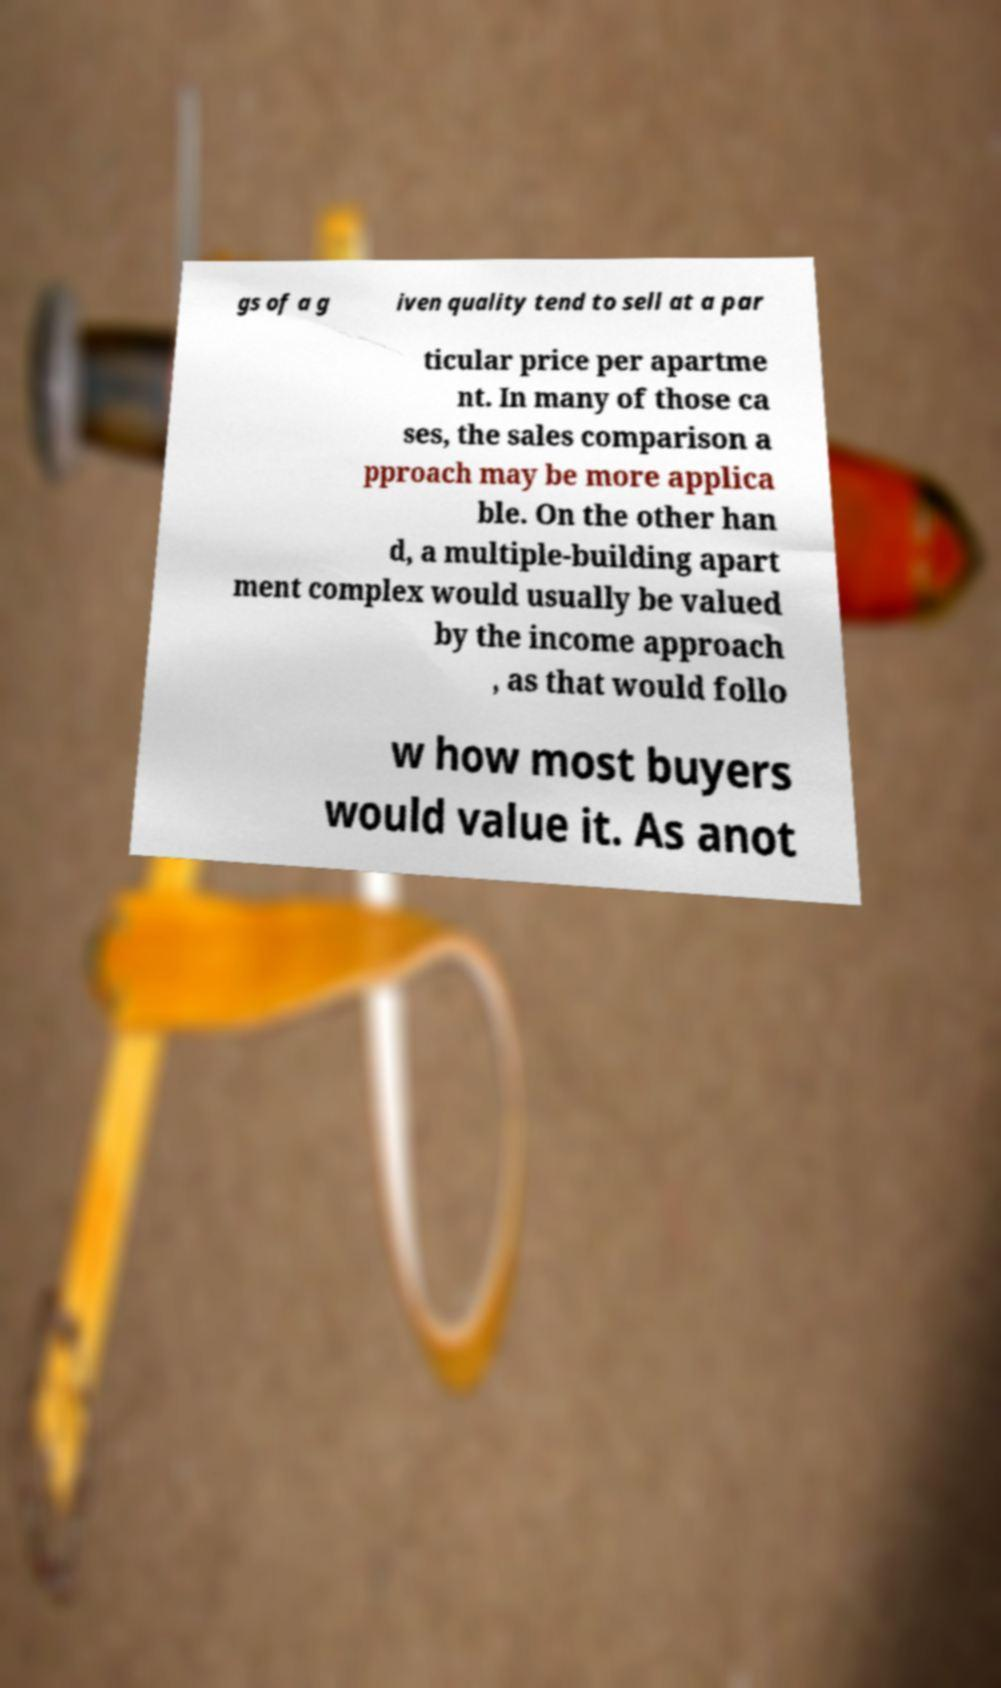There's text embedded in this image that I need extracted. Can you transcribe it verbatim? gs of a g iven quality tend to sell at a par ticular price per apartme nt. In many of those ca ses, the sales comparison a pproach may be more applica ble. On the other han d, a multiple-building apart ment complex would usually be valued by the income approach , as that would follo w how most buyers would value it. As anot 